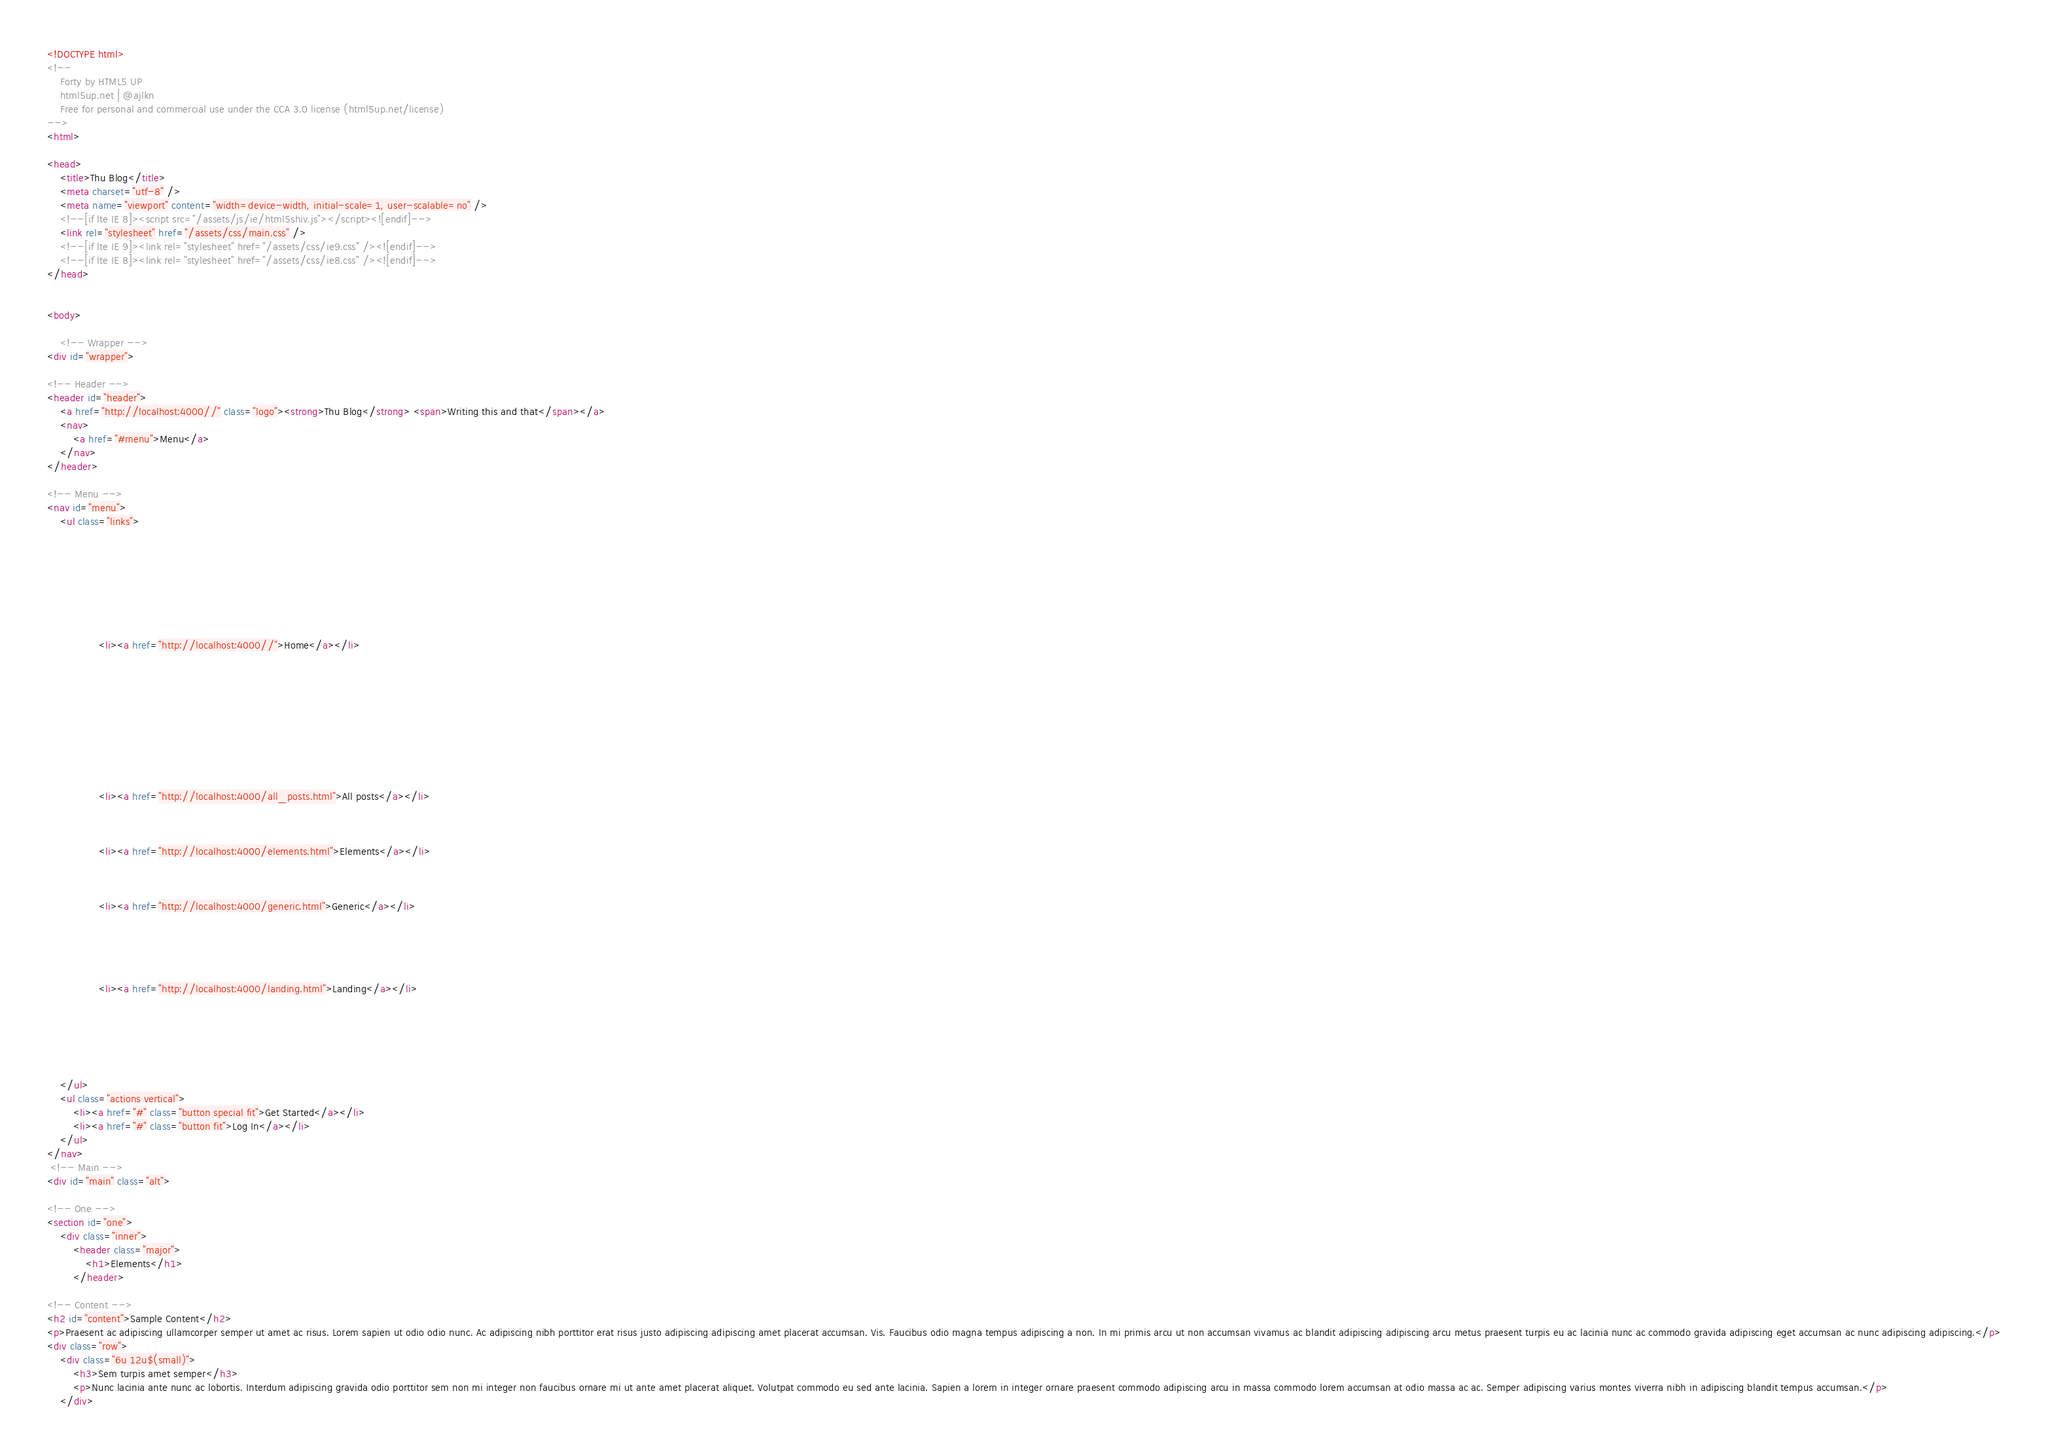Convert code to text. <code><loc_0><loc_0><loc_500><loc_500><_HTML_><!DOCTYPE html>
<!--
	Forty by HTML5 UP
	html5up.net | @ajlkn
	Free for personal and commercial use under the CCA 3.0 license (html5up.net/license)
-->
<html>

<head>
	<title>Thu Blog</title>
	<meta charset="utf-8" />
	<meta name="viewport" content="width=device-width, initial-scale=1, user-scalable=no" />
	<!--[if lte IE 8]><script src="/assets/js/ie/html5shiv.js"></script><![endif]-->
	<link rel="stylesheet" href="/assets/css/main.css" />
	<!--[if lte IE 9]><link rel="stylesheet" href="/assets/css/ie9.css" /><![endif]-->
	<!--[if lte IE 8]><link rel="stylesheet" href="/assets/css/ie8.css" /><![endif]-->
</head>


<body>

    <!-- Wrapper -->
<div id="wrapper">

<!-- Header -->
<header id="header">
	<a href="http://localhost:4000//" class="logo"><strong>Thu Blog</strong> <span>Writing this and that</span></a>
	<nav>
		<a href="#menu">Menu</a>
	</nav>
</header>

<!-- Menu -->
<nav id="menu">
	<ul class="links">
        
		    
		
		    
		
		    
		
		    
		        <li><a href="http://localhost:4000//">Home</a></li>
	    	
		
		    
		
		    
		
		    
		
		
		    
		        <li><a href="http://localhost:4000/all_posts.html">All posts</a></li>
		    
		
		    
		        <li><a href="http://localhost:4000/elements.html">Elements</a></li>
		    
		
		    
		        <li><a href="http://localhost:4000/generic.html">Generic</a></li>
		    
		
		    
		
		    
		        <li><a href="http://localhost:4000/landing.html">Landing</a></li>
		    
		
		    
		
		    
		
	</ul>
	<ul class="actions vertical">
		<li><a href="#" class="button special fit">Get Started</a></li>
		<li><a href="#" class="button fit">Log In</a></li>
	</ul>
</nav>
 <!-- Main -->
<div id="main" class="alt">

<!-- One -->
<section id="one">
	<div class="inner">
		<header class="major">
			<h1>Elements</h1>
		</header>

<!-- Content -->
<h2 id="content">Sample Content</h2>
<p>Praesent ac adipiscing ullamcorper semper ut amet ac risus. Lorem sapien ut odio odio nunc. Ac adipiscing nibh porttitor erat risus justo adipiscing adipiscing amet placerat accumsan. Vis. Faucibus odio magna tempus adipiscing a non. In mi primis arcu ut non accumsan vivamus ac blandit adipiscing adipiscing arcu metus praesent turpis eu ac lacinia nunc ac commodo gravida adipiscing eget accumsan ac nunc adipiscing adipiscing.</p>
<div class="row">
	<div class="6u 12u$(small)">
		<h3>Sem turpis amet semper</h3>
		<p>Nunc lacinia ante nunc ac lobortis. Interdum adipiscing gravida odio porttitor sem non mi integer non faucibus ornare mi ut ante amet placerat aliquet. Volutpat commodo eu sed ante lacinia. Sapien a lorem in integer ornare praesent commodo adipiscing arcu in massa commodo lorem accumsan at odio massa ac ac. Semper adipiscing varius montes viverra nibh in adipiscing blandit tempus accumsan.</p>
	</div></code> 